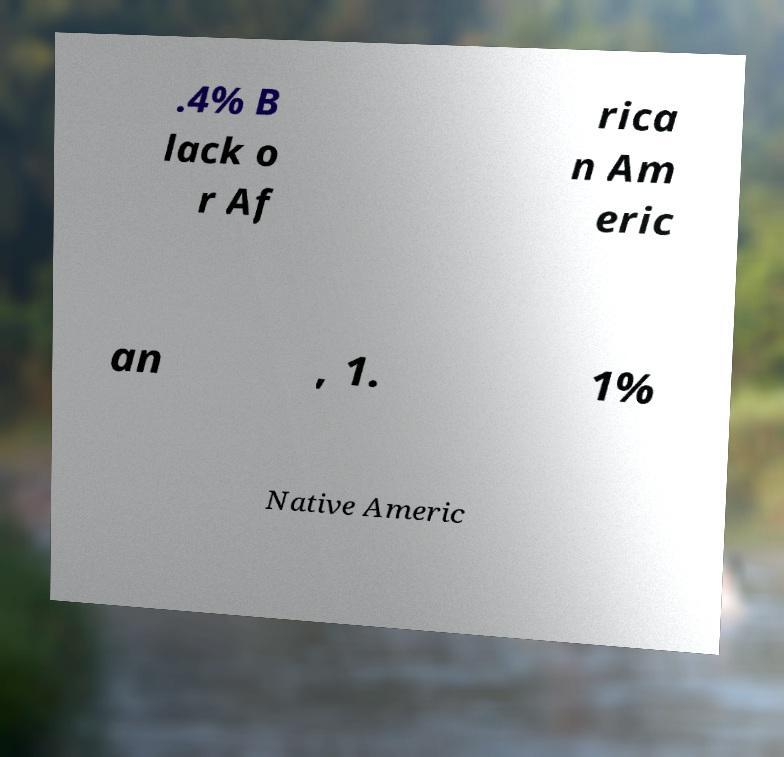Could you assist in decoding the text presented in this image and type it out clearly? .4% B lack o r Af rica n Am eric an , 1. 1% Native Americ 